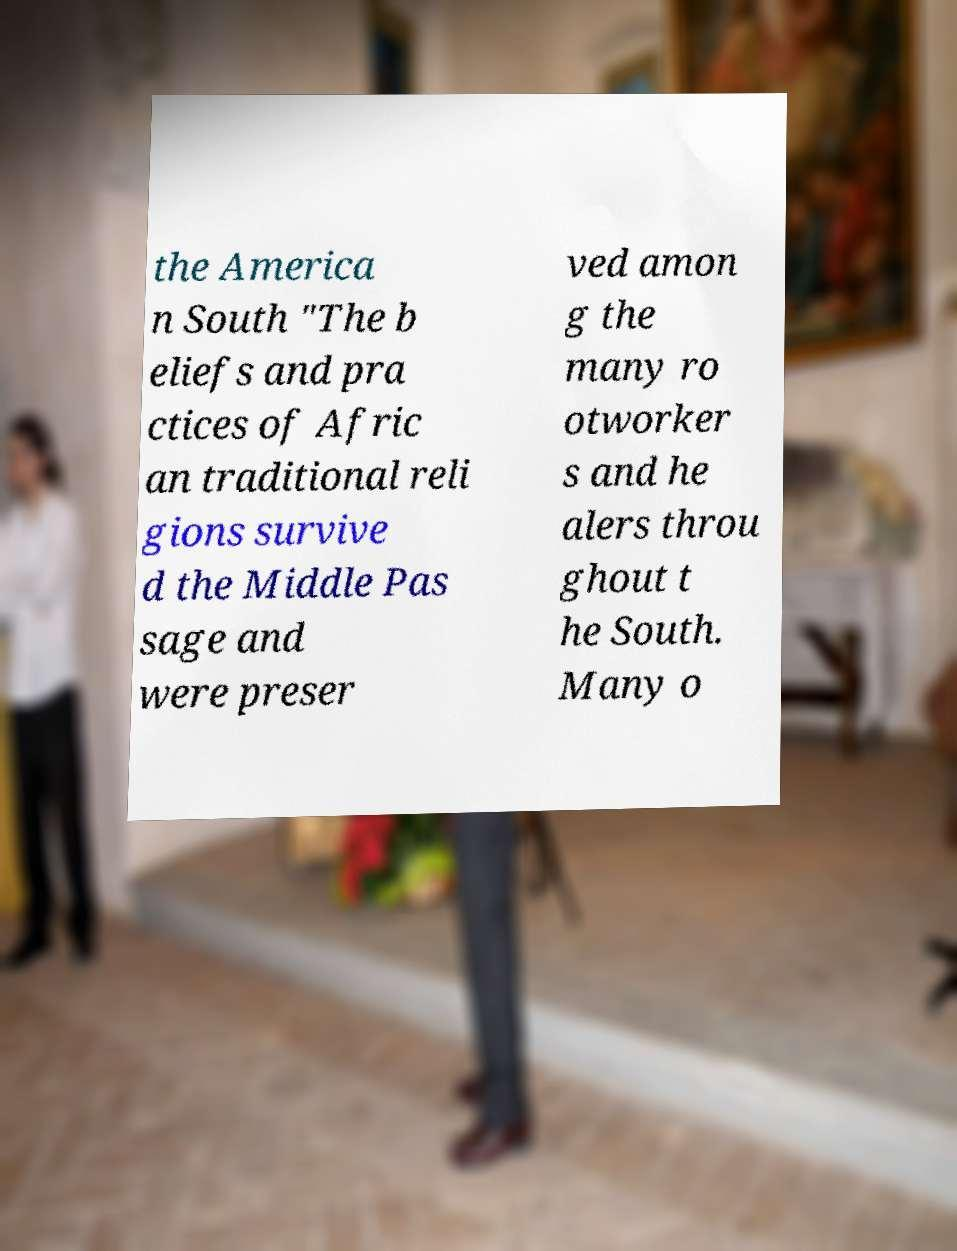Could you assist in decoding the text presented in this image and type it out clearly? the America n South "The b eliefs and pra ctices of Afric an traditional reli gions survive d the Middle Pas sage and were preser ved amon g the many ro otworker s and he alers throu ghout t he South. Many o 